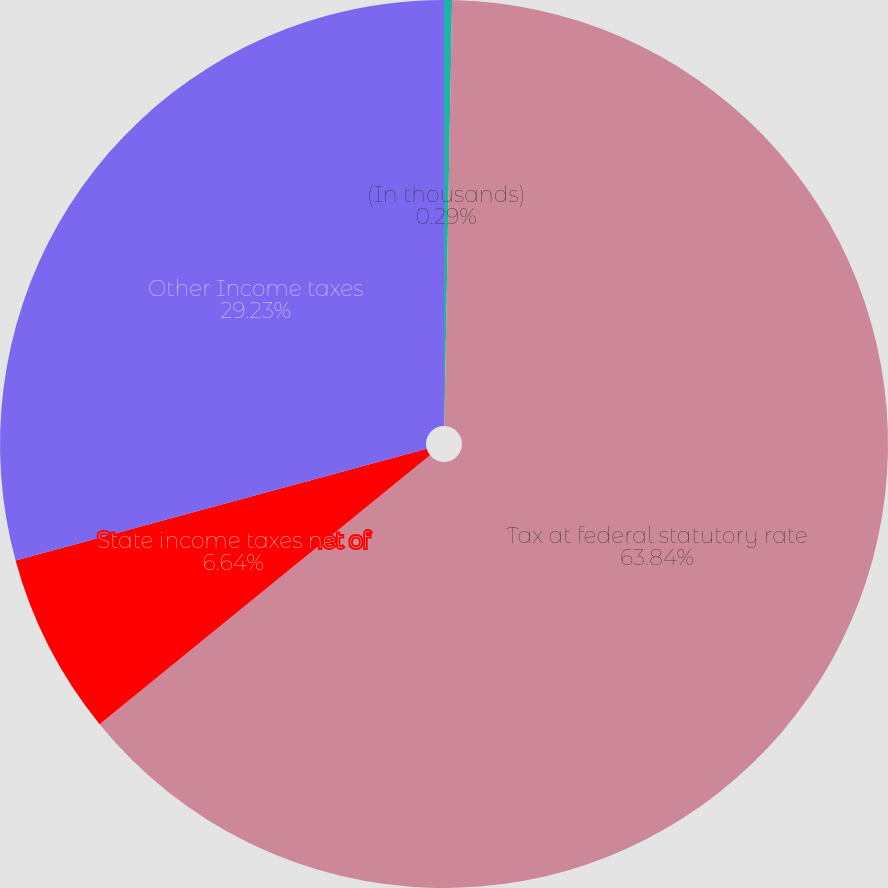Convert chart to OTSL. <chart><loc_0><loc_0><loc_500><loc_500><pie_chart><fcel>(In thousands)<fcel>Tax at federal statutory rate<fcel>State income taxes net of<fcel>Other Income taxes<nl><fcel>0.29%<fcel>63.84%<fcel>6.64%<fcel>29.23%<nl></chart> 